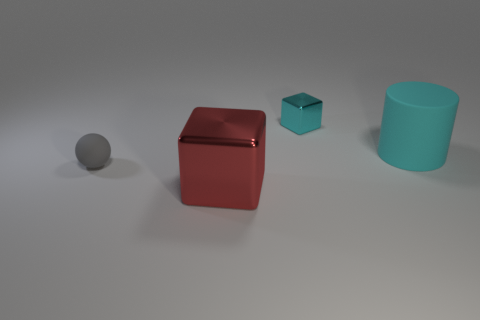What is the color of the shiny block in front of the block behind the tiny gray rubber object?
Keep it short and to the point. Red. How many objects are things that are on the right side of the cyan shiny thing or spheres?
Make the answer very short. 2. There is a sphere; is its size the same as the object in front of the small gray rubber thing?
Ensure brevity in your answer.  No. What number of tiny things are shiny cubes or cylinders?
Give a very brief answer. 1. There is a tiny cyan metal object; what shape is it?
Your answer should be very brief. Cube. The cylinder that is the same color as the tiny block is what size?
Provide a short and direct response. Large. Are there any other blocks that have the same material as the red cube?
Provide a short and direct response. Yes. Are there more big cyan matte things than tiny yellow metal cylinders?
Provide a short and direct response. Yes. Is the material of the cyan cylinder the same as the red cube?
Make the answer very short. No. What number of rubber objects are gray things or big cyan things?
Your answer should be very brief. 2. 